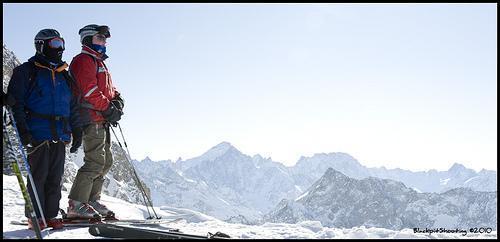How many people are wearing their goggles?
Give a very brief answer. 1. How many people are wearing hats?
Give a very brief answer. 2. How many people are in the photo?
Give a very brief answer. 2. 